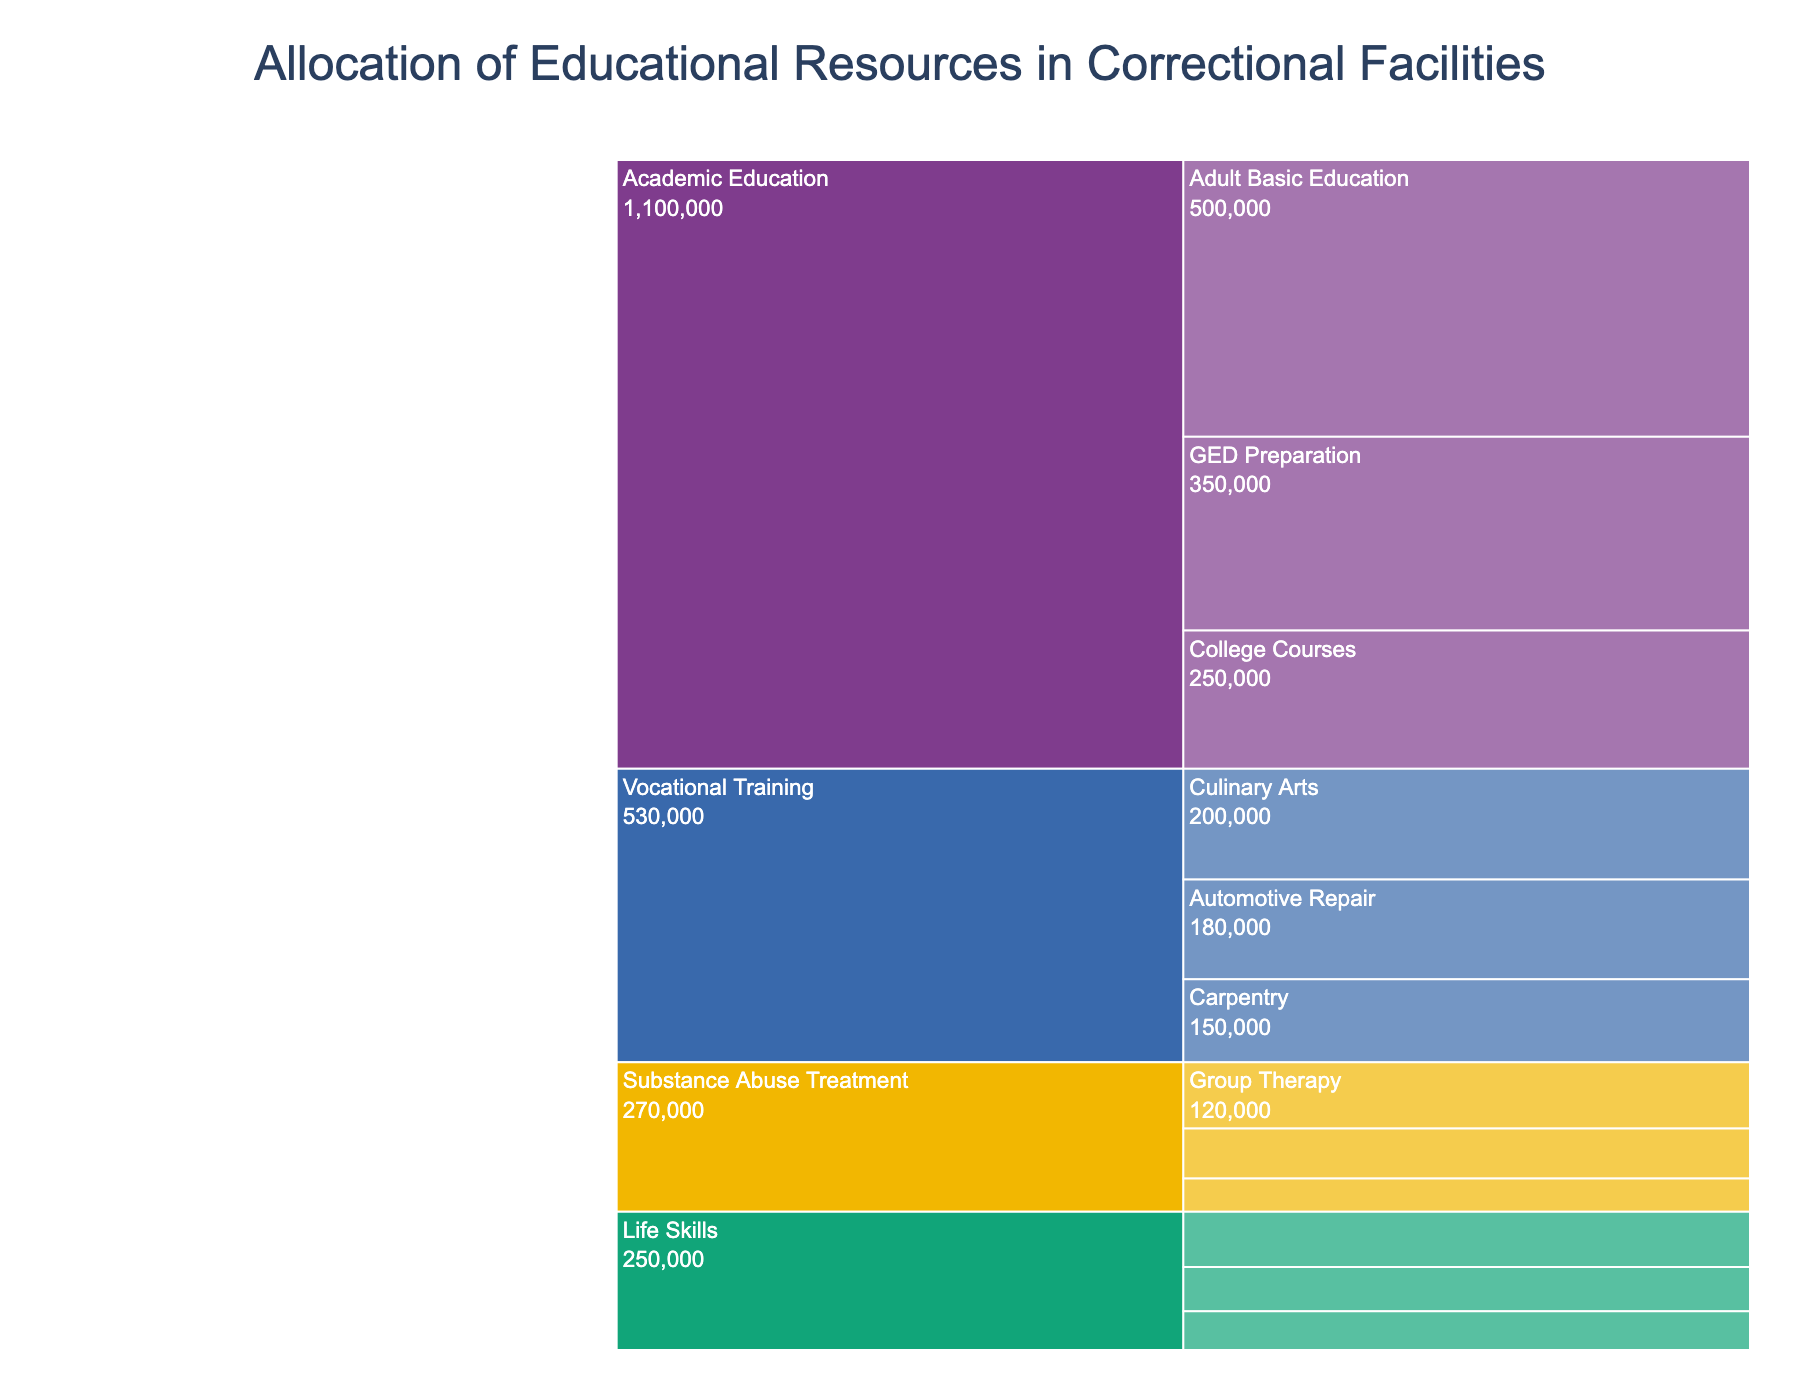What is the title of the figure? The title is usually presented at the top of the chart, summarizing its content. Look at the top of the chart to find the title.
Answer: Allocation of Educational Resources in Correctional Facilities Which program has the highest allocation of resources? Identify the program with the largest segment or the one that has the highest numerical value. The largest section in the chart or the highest dollar amount in the data.
Answer: Academic Education How much is allocated to Anger Management classes? Locate "Anger Management" under the "Life Skills" program in the chart and read its value.
Answer: $100,000 What is the total allocation for Vocational Training programs? Add the allocations for all subprograms under the "Vocational Training" category: Culinary Arts ($200,000) + Automotive Repair ($180,000) + Carpentry ($150,000).
Answer: $530,000 Which subprogram under Academic Education has the lowest allocation? Compare the allocations for Adult Basic Education, GED Preparation, and College Courses. The one with the lowest value is the answer.
Answer: College Courses Compare the allocation for Substance Abuse Treatment programs to Life Skills programs. Which has more funding? Sum the allocations for all subprograms under Substance Abuse Treatment and Life Skills, then compare these sums: (Group Therapy $120,000 + Individual Counseling $90,000 + Relapse Prevention $60,000) vs. (Anger Management $100,000 + Financial Literacy $80,000 + Parenting Classes $70,000).
Answer: Life Skills What is the total allocation for all programs combined? Sum the allocation of funds for all subprograms: $500,000 + $350,000 + $250,000 + $200,000 + $180,000 + $150,000 + $100,000 + $80,000 + $70,000 + $120,000 + $90,000 + $60,000.
Answer: $2,150,000 Which program has the smallest overall allocation? Compare the total allocations for Academic Education, Vocational Training, Life Skills, and Substance Abuse Treatment, and identify the smallest one.
Answer: Substance Abuse Treatment What percentage of the total allocation is dedicated to GED Preparation? Divide the allocation for GED Preparation by the total allocation and multiply by 100: ($350,000 / $2,150,000) * 100.
Answer: ~16.28% What is the average allocation per subprogram under Vocational Training? Sum the allocations for Culinary Arts, Automotive Repair, and Carpentry, then divide by the number of subprograms: ($200,000 + $180,000 + $150,000) / 3.
Answer: $176,666.67 